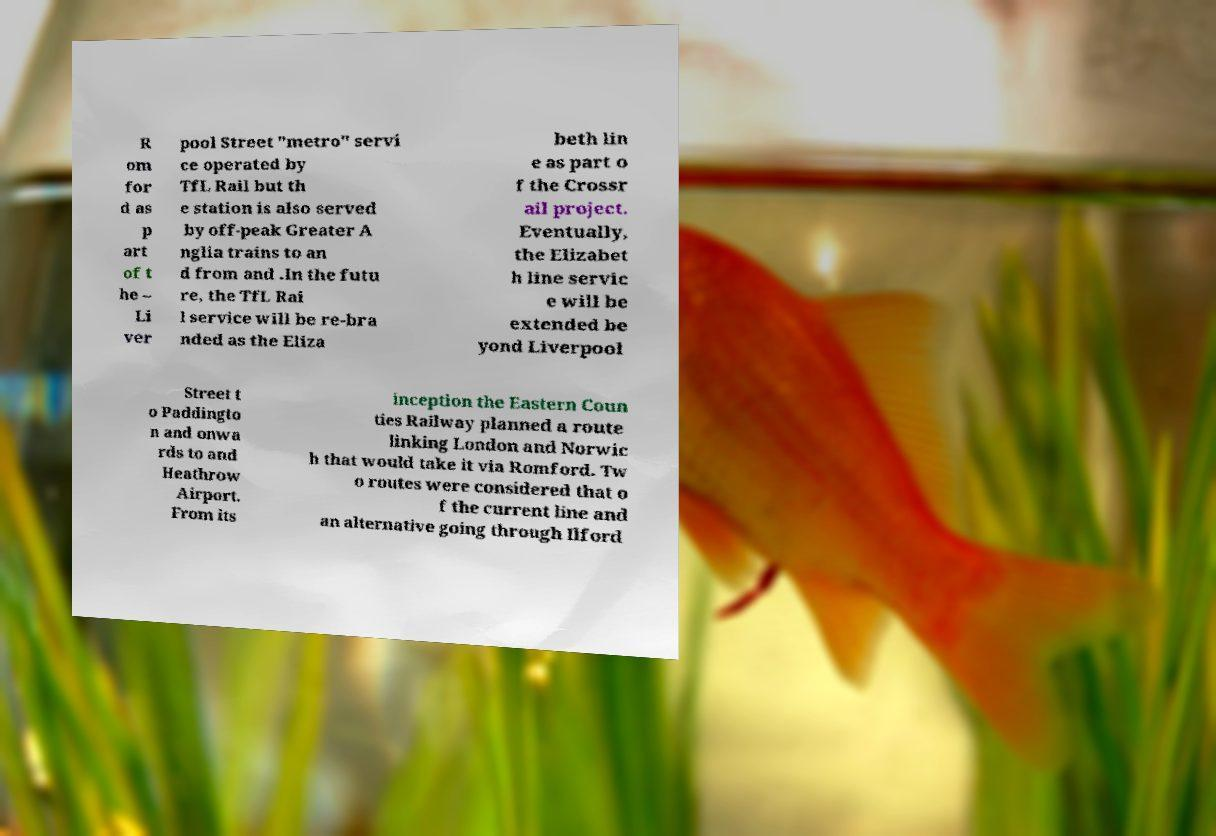What messages or text are displayed in this image? I need them in a readable, typed format. R om for d as p art of t he – Li ver pool Street "metro" servi ce operated by TfL Rail but th e station is also served by off-peak Greater A nglia trains to an d from and .In the futu re, the TfL Rai l service will be re-bra nded as the Eliza beth lin e as part o f the Crossr ail project. Eventually, the Elizabet h line servic e will be extended be yond Liverpool Street t o Paddingto n and onwa rds to and Heathrow Airport. From its inception the Eastern Coun ties Railway planned a route linking London and Norwic h that would take it via Romford. Tw o routes were considered that o f the current line and an alternative going through Ilford 